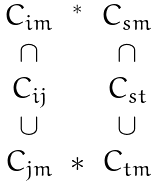Convert formula to latex. <formula><loc_0><loc_0><loc_500><loc_500>\begin{array} { c c c } C _ { i m } & ^ { * } & C _ { s m } \\ \cap & & \cap \\ C _ { i j } & & C _ { s t } \\ \cup & & \cup \\ C _ { j m } & \ast & C _ { t m } \end{array}</formula> 